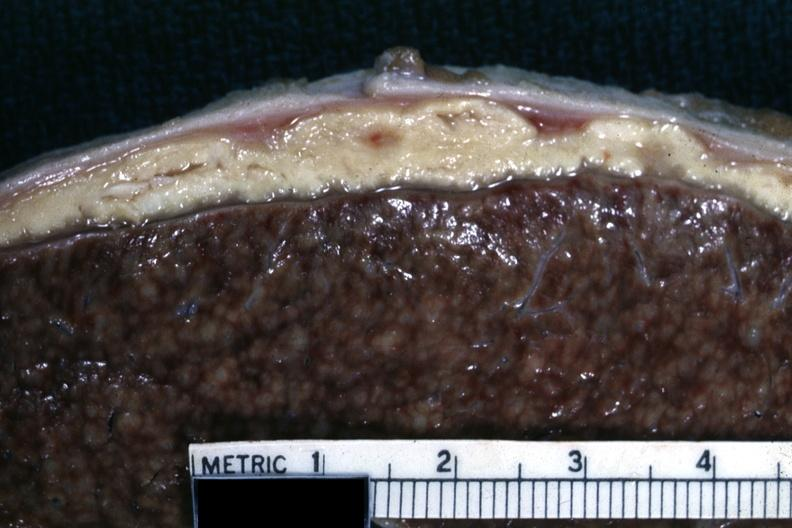s this cold abscess material very typical?
Answer the question using a single word or phrase. Yes 